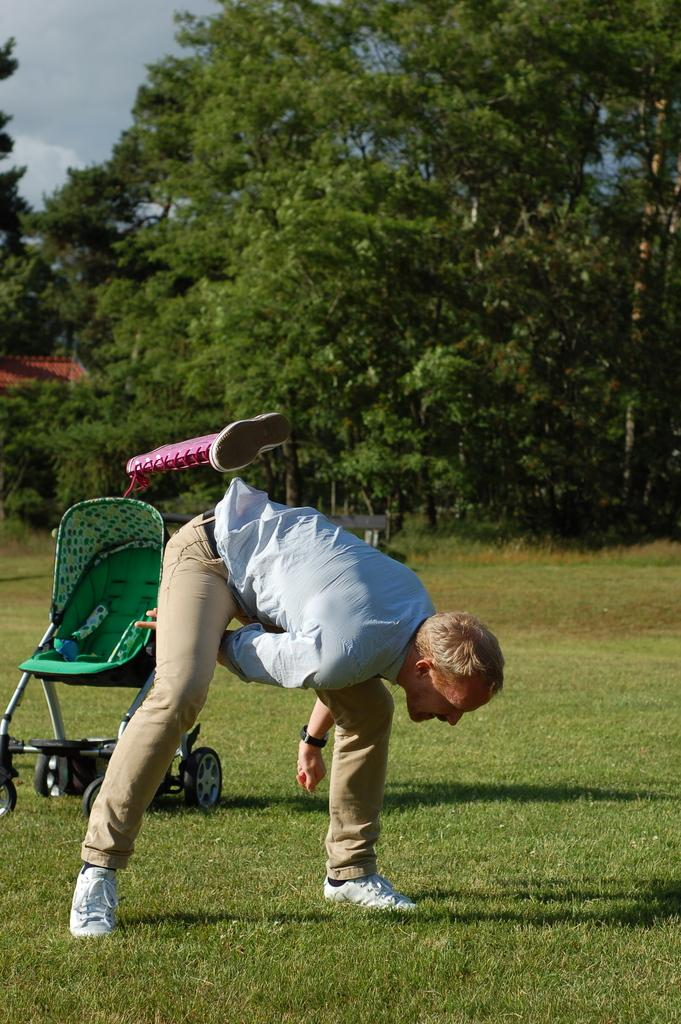Who or what is in the image? There is a person in the image. What is the person standing or sitting on? The person is on green grass. What object can be seen in the image that is typically used for babies? There is a wheel cradle in the image. What type of natural environment is visible in the image? There are trees in the image. What is visible in the sky in the image? Clouds are visible in the sky. What sense is being stimulated by the structure in the image? There is no structure present in the image that would stimulate a sense. 